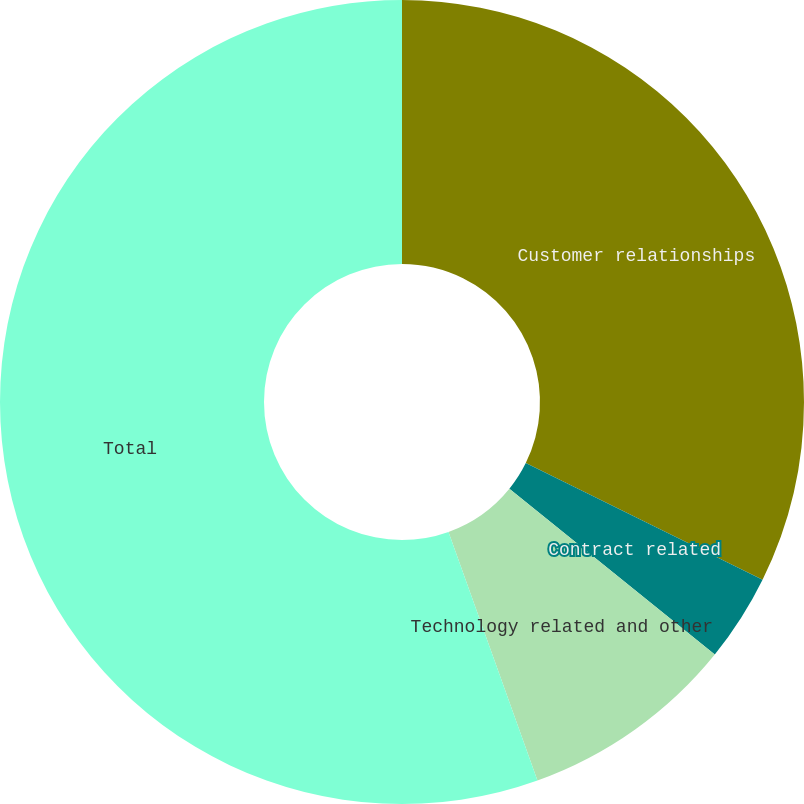<chart> <loc_0><loc_0><loc_500><loc_500><pie_chart><fcel>Customer relationships<fcel>Contract related<fcel>Technology related and other<fcel>Total<nl><fcel>32.29%<fcel>3.52%<fcel>8.72%<fcel>55.47%<nl></chart> 